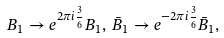<formula> <loc_0><loc_0><loc_500><loc_500>B _ { 1 } \to e ^ { 2 \pi i \frac { 3 } { 6 } } B _ { 1 } , \, \bar { B } _ { 1 } \to e ^ { - 2 \pi i \frac { 3 } { 6 } } \bar { B } _ { 1 } ,</formula> 